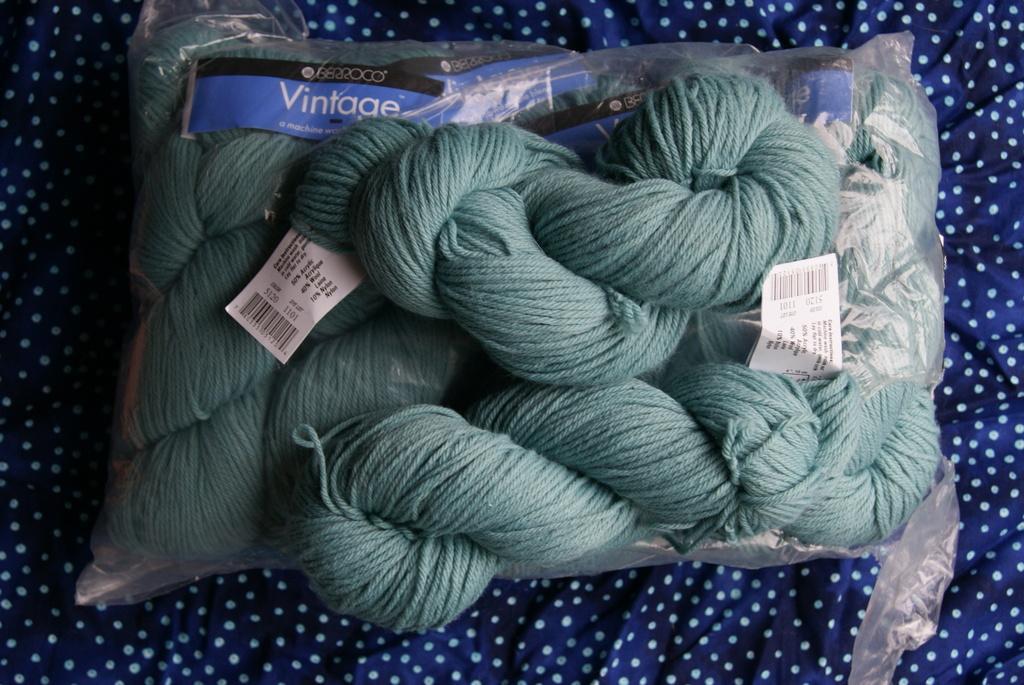Could you give a brief overview of what you see in this image? In this image we can see some woolen bundles in a cover and some papers with text on it which are placed on a cloth. 